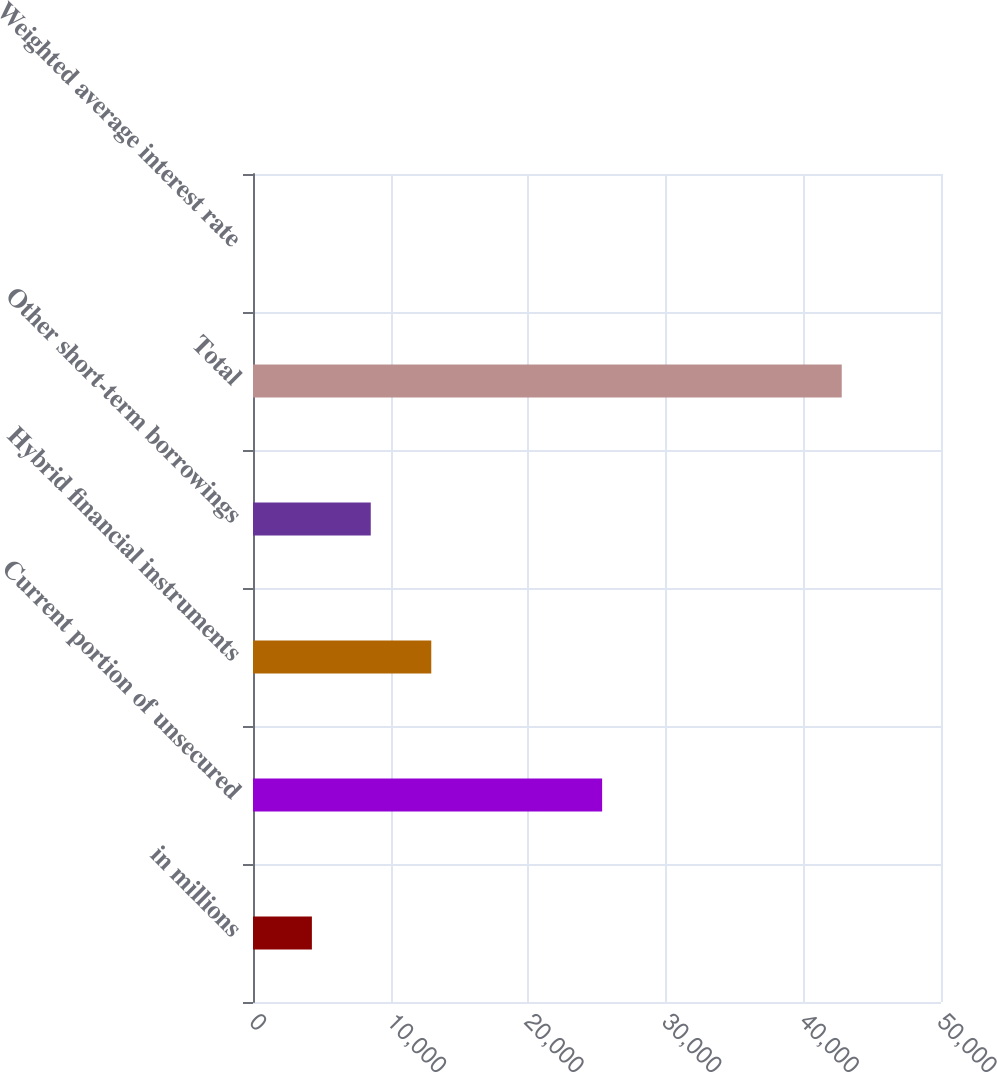Convert chart to OTSL. <chart><loc_0><loc_0><loc_500><loc_500><bar_chart><fcel>in millions<fcel>Current portion of unsecured<fcel>Hybrid financial instruments<fcel>Other short-term borrowings<fcel>Total<fcel>Weighted average interest rate<nl><fcel>4280.07<fcel>25373<fcel>12956<fcel>8558.62<fcel>42787<fcel>1.52<nl></chart> 